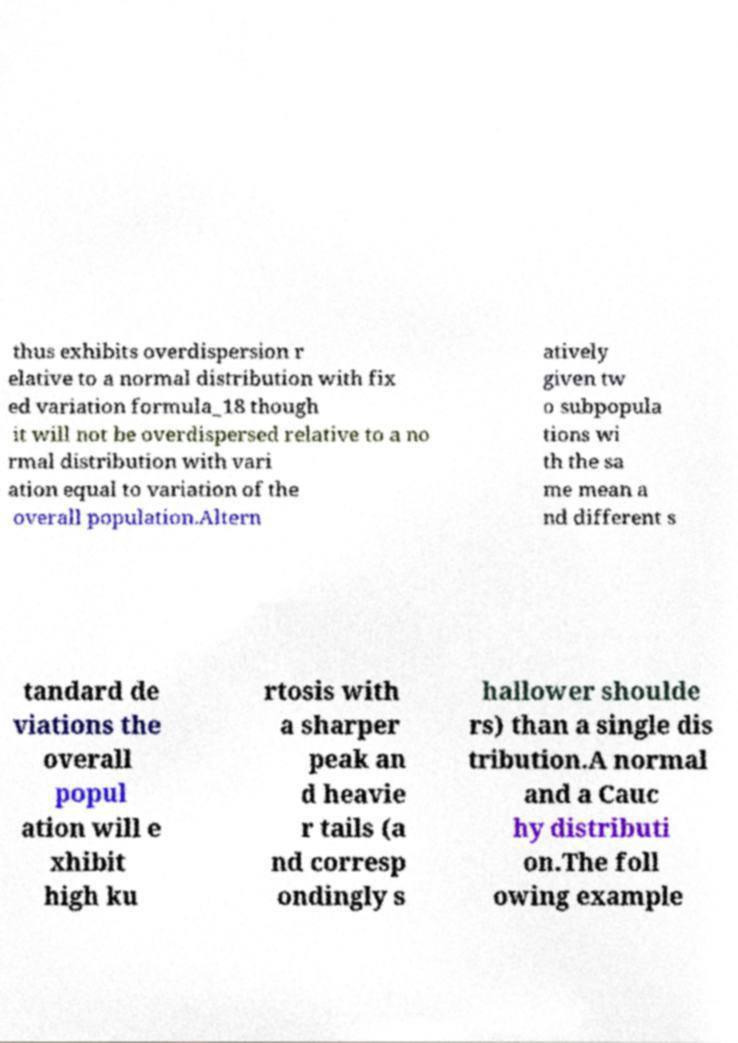I need the written content from this picture converted into text. Can you do that? thus exhibits overdispersion r elative to a normal distribution with fix ed variation formula_18 though it will not be overdispersed relative to a no rmal distribution with vari ation equal to variation of the overall population.Altern atively given tw o subpopula tions wi th the sa me mean a nd different s tandard de viations the overall popul ation will e xhibit high ku rtosis with a sharper peak an d heavie r tails (a nd corresp ondingly s hallower shoulde rs) than a single dis tribution.A normal and a Cauc hy distributi on.The foll owing example 